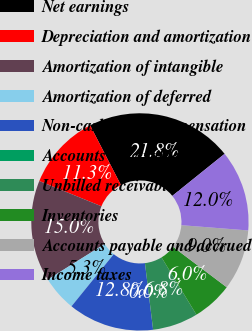<chart> <loc_0><loc_0><loc_500><loc_500><pie_chart><fcel>Net earnings<fcel>Depreciation and amortization<fcel>Amortization of intangible<fcel>Amortization of deferred<fcel>Non-cash stock compensation<fcel>Accounts receivable<fcel>Unbilled receivables<fcel>Inventories<fcel>Accounts payable and accrued<fcel>Income taxes<nl><fcel>21.8%<fcel>11.28%<fcel>15.04%<fcel>5.26%<fcel>12.78%<fcel>0.0%<fcel>6.77%<fcel>6.02%<fcel>9.02%<fcel>12.03%<nl></chart> 